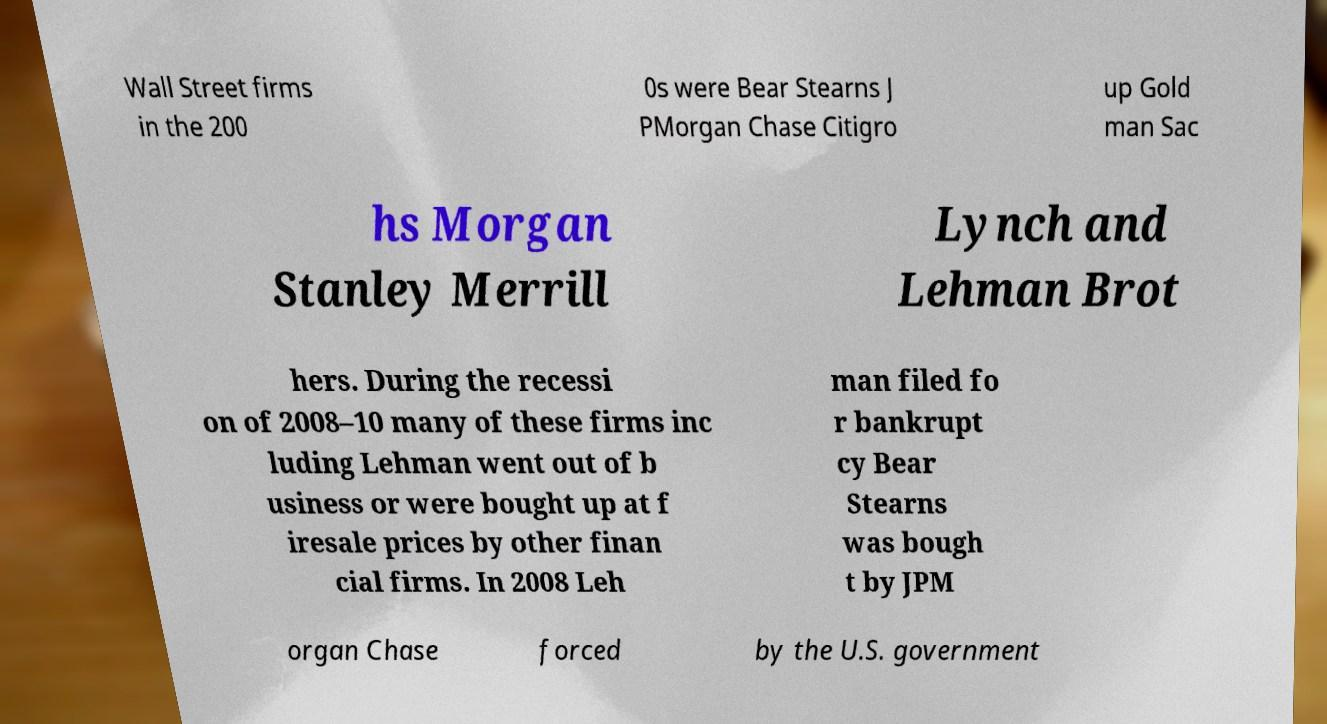Can you read and provide the text displayed in the image?This photo seems to have some interesting text. Can you extract and type it out for me? Wall Street firms in the 200 0s were Bear Stearns J PMorgan Chase Citigro up Gold man Sac hs Morgan Stanley Merrill Lynch and Lehman Brot hers. During the recessi on of 2008–10 many of these firms inc luding Lehman went out of b usiness or were bought up at f iresale prices by other finan cial firms. In 2008 Leh man filed fo r bankrupt cy Bear Stearns was bough t by JPM organ Chase forced by the U.S. government 